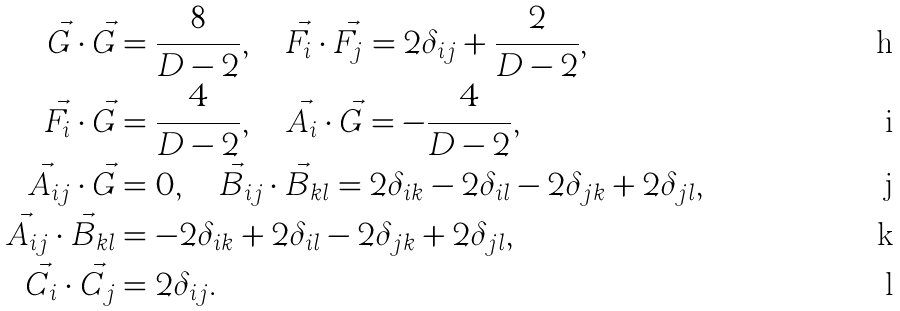Convert formula to latex. <formula><loc_0><loc_0><loc_500><loc_500>\vec { G } \cdot \vec { G } & = \frac { 8 } { D - 2 } , \quad \vec { F } _ { i } \cdot \vec { F } _ { j } = 2 \delta _ { i j } + \frac { 2 } { D - 2 } , \\ \vec { F } _ { i } \cdot \vec { G } & = \frac { 4 } { D - 2 } , \quad \vec { A } _ { i } \cdot \vec { G } = - \frac { 4 } { D - 2 } , \\ \vec { A } _ { i j } \cdot \vec { G } & = 0 , \quad \vec { B } _ { i j } \cdot \vec { B } _ { k l } = 2 \delta _ { i k } - 2 \delta _ { i l } - 2 \delta _ { j k } + 2 \delta _ { j l } , \\ \vec { A } _ { i j } \cdot \vec { B } _ { k l } & = - 2 \delta _ { i k } + 2 \delta _ { i l } - 2 \delta _ { j k } + 2 \delta _ { j l } , \\ \vec { C } _ { i } \cdot \vec { C } _ { j } & = 2 \delta _ { i j } .</formula> 